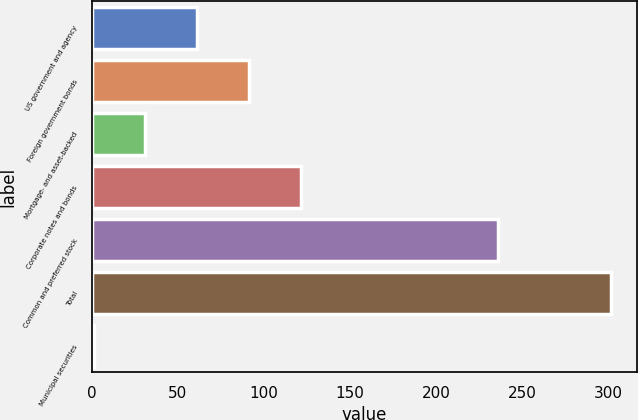Convert chart. <chart><loc_0><loc_0><loc_500><loc_500><bar_chart><fcel>US government and agency<fcel>Foreign government bonds<fcel>Mortgage- and asset-backed<fcel>Corporate notes and bonds<fcel>Common and preferred stock<fcel>Total<fcel>Municipal securities<nl><fcel>61.2<fcel>91.3<fcel>31.1<fcel>121.4<fcel>236<fcel>302<fcel>1<nl></chart> 